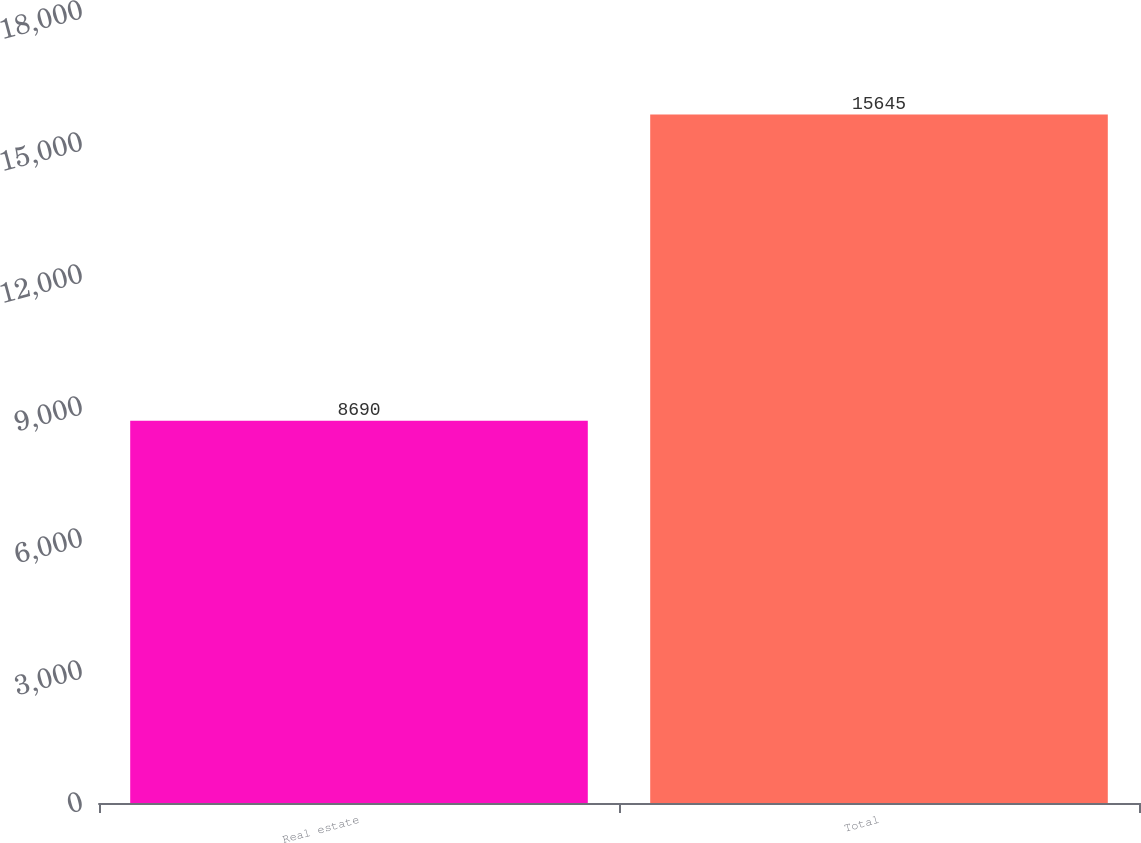<chart> <loc_0><loc_0><loc_500><loc_500><bar_chart><fcel>Real estate<fcel>Total<nl><fcel>8690<fcel>15645<nl></chart> 